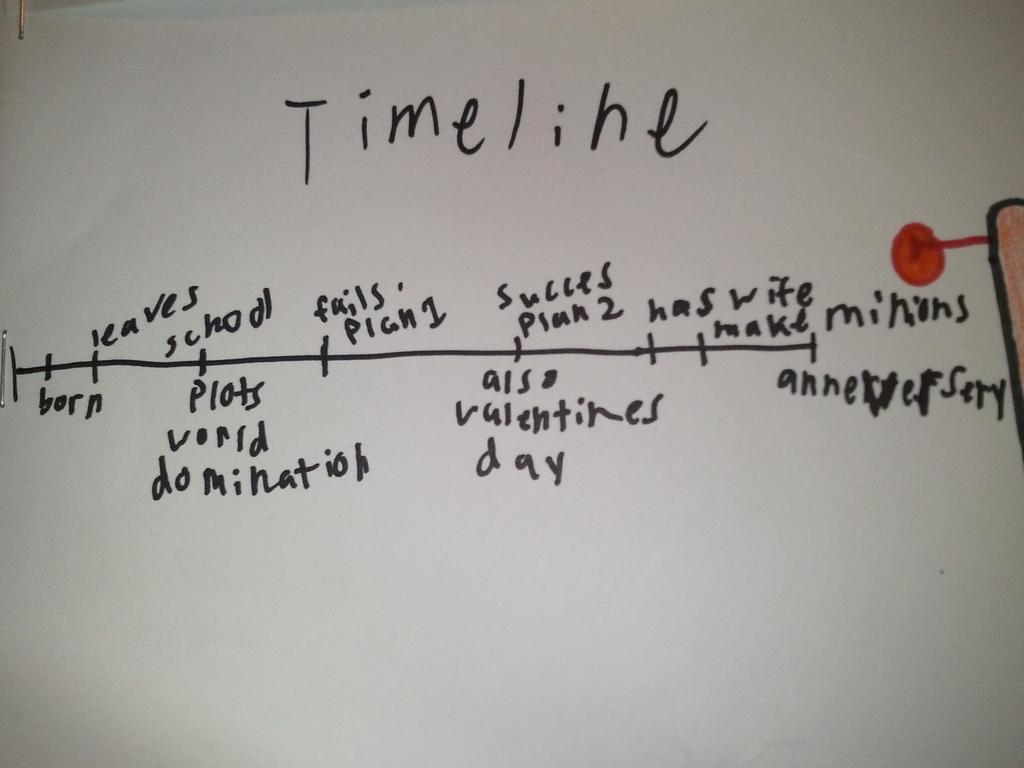<image>
Offer a succinct explanation of the picture presented. A handwritten timeline goes from birth to anniversary. 